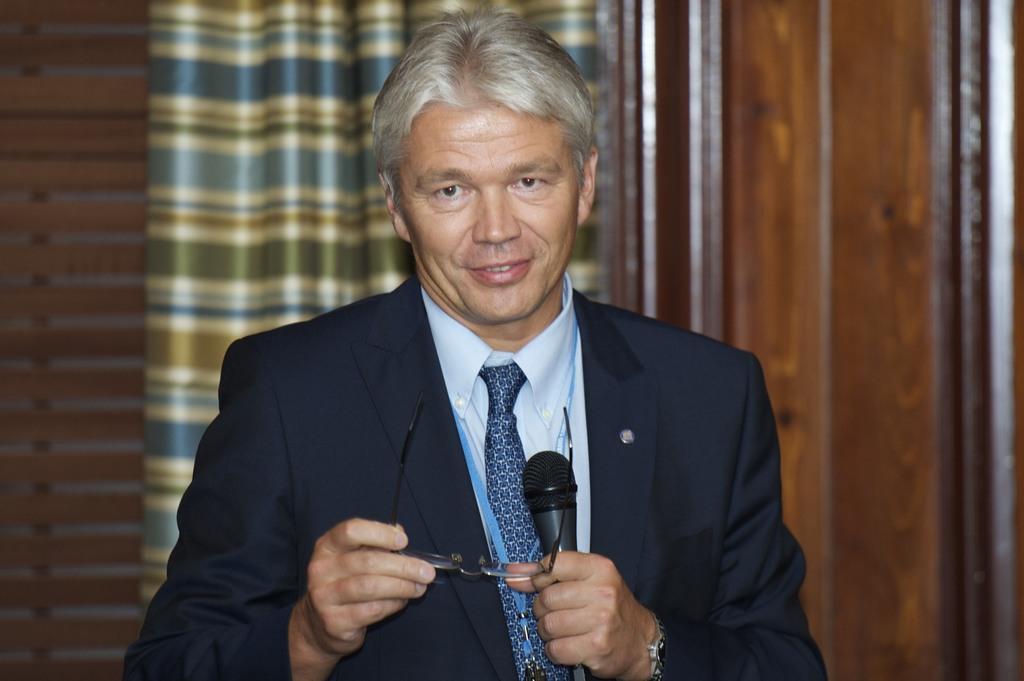In one or two sentences, can you explain what this image depicts? In this image there is one person and he is holding spectacles and one mike, and on the background there is one curtain and one wooden wall is there on the right side. 